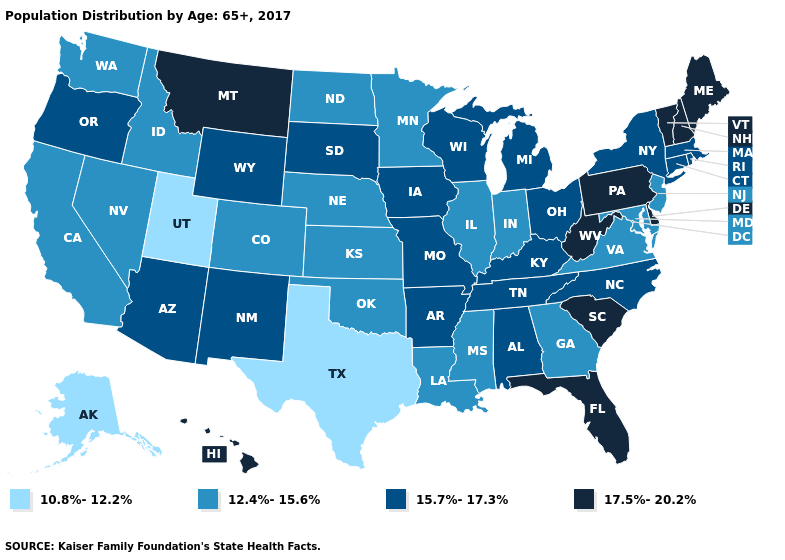What is the value of Colorado?
Answer briefly. 12.4%-15.6%. Does New Hampshire have the highest value in the Northeast?
Be succinct. Yes. Does the map have missing data?
Answer briefly. No. Name the states that have a value in the range 15.7%-17.3%?
Keep it brief. Alabama, Arizona, Arkansas, Connecticut, Iowa, Kentucky, Massachusetts, Michigan, Missouri, New Mexico, New York, North Carolina, Ohio, Oregon, Rhode Island, South Dakota, Tennessee, Wisconsin, Wyoming. What is the value of Indiana?
Be succinct. 12.4%-15.6%. Does Alaska have the lowest value in the USA?
Answer briefly. Yes. What is the value of Ohio?
Concise answer only. 15.7%-17.3%. What is the value of Rhode Island?
Answer briefly. 15.7%-17.3%. Does Vermont have the highest value in the USA?
Keep it brief. Yes. Name the states that have a value in the range 10.8%-12.2%?
Keep it brief. Alaska, Texas, Utah. Does Kansas have the lowest value in the MidWest?
Concise answer only. Yes. What is the value of Oklahoma?
Give a very brief answer. 12.4%-15.6%. Among the states that border Minnesota , does North Dakota have the highest value?
Keep it brief. No. What is the value of Missouri?
Answer briefly. 15.7%-17.3%. Which states have the highest value in the USA?
Be succinct. Delaware, Florida, Hawaii, Maine, Montana, New Hampshire, Pennsylvania, South Carolina, Vermont, West Virginia. 